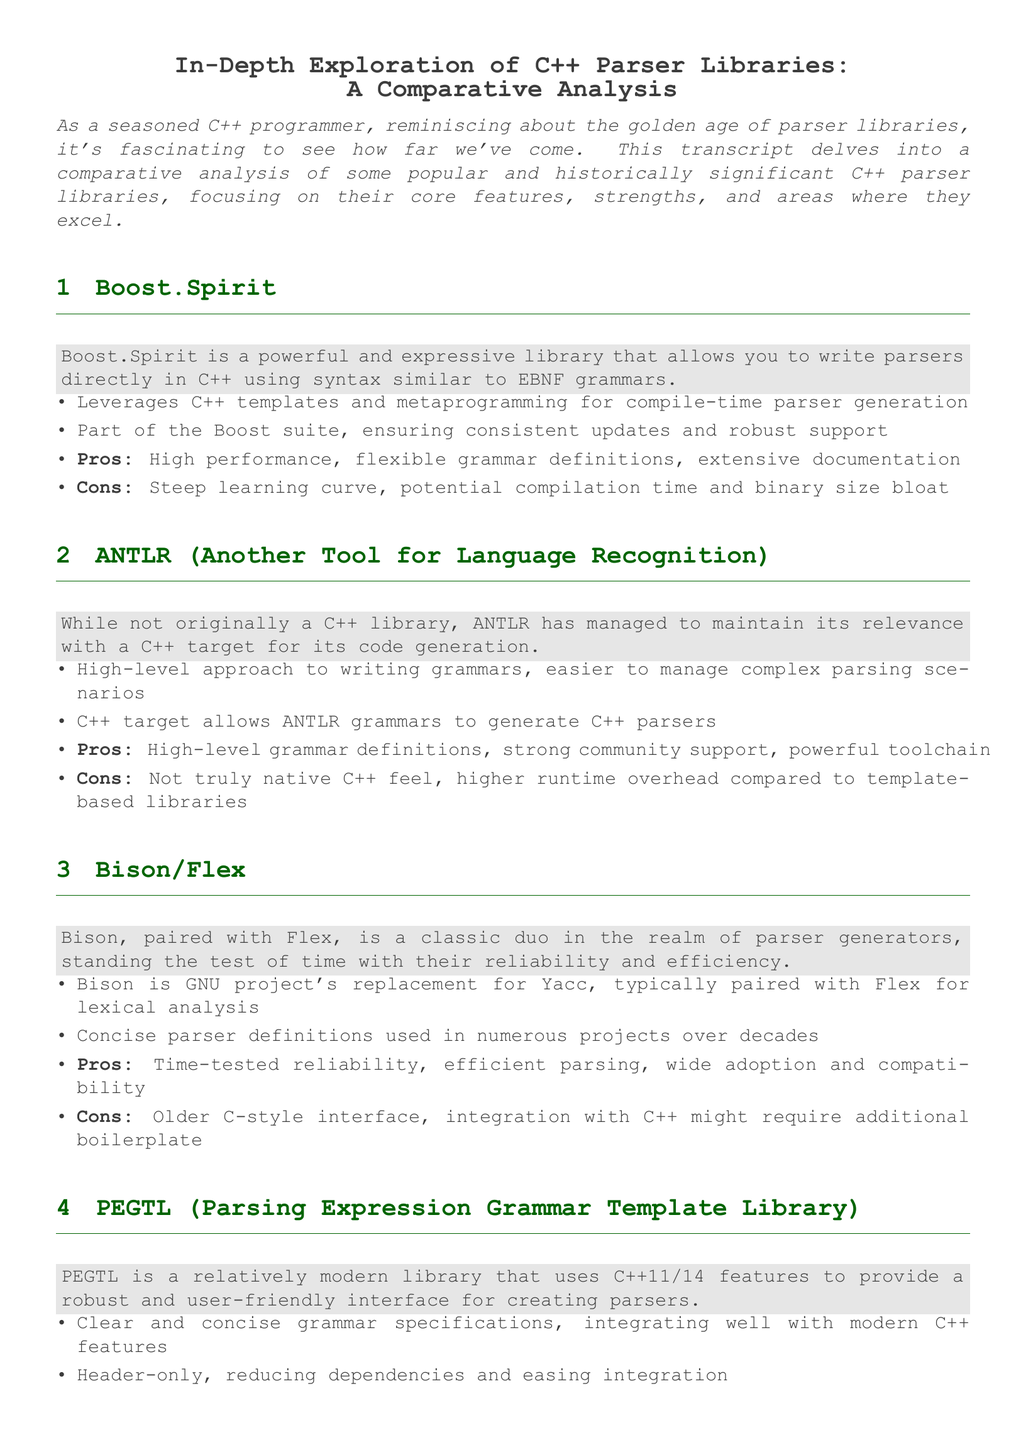What is the title of the document? The title is prominently displayed at the top of the document, indicating the subject of the content.
Answer: In-Depth Exploration of C++ Parser Libraries: A Comparative Analysis What library is part of the Boost suite? Boost.Spirit is explicitly mentioned as being part of the Boost suite in the document.
Answer: Boost.Spirit What is a high-level advantage of ANTLR? The document lists a high-level approach for ANTLR, which simplifies managing complex parsing scenarios.
Answer: Easier to manage complex parsing scenarios Which library is a classic duo in the realm of parser generators? Bison and Flex are both introduced together as a long-standing, reliable duo in parsing.
Answer: Bison/Flex What is the primary interface style of PEGTL? The document describes PEGTL as using modern C++ features, indicating a new style of interface.
Answer: Modern C++ integration What is a noted con of Boost.Spirit? The document mentions potential downsides of Boost.Spirit including a steep learning curve.
Answer: Steep learning curve How is Bison commonly paired in its functionality? The document states that Bison is typically paired with Flex for lexical analysis tasks.
Answer: With Flex What is a unique feature of PEGTL compared to older libraries? PEGTL is noted for being header-only, which simplifies its integration process.
Answer: Header-only What type of parser does ANTLR generate? ANTLR is indicated to generate parsers specifically targeted for C++.
Answer: C++ parsers 